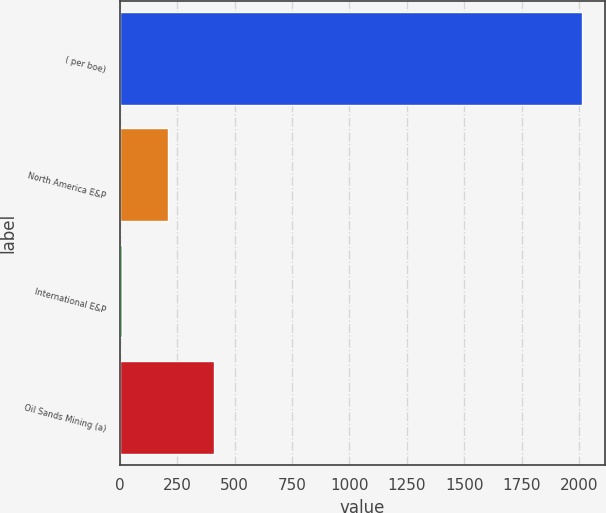Convert chart. <chart><loc_0><loc_0><loc_500><loc_500><bar_chart><fcel>( per boe)<fcel>North America E&P<fcel>International E&P<fcel>Oil Sands Mining (a)<nl><fcel>2014<fcel>208.88<fcel>8.31<fcel>409.45<nl></chart> 